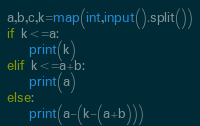<code> <loc_0><loc_0><loc_500><loc_500><_Python_>a,b,c,k=map(int,input().split())
if k<=a:
    print(k)
elif k<=a+b:
    print(a)
else:
    print(a-(k-(a+b)))
</code> 